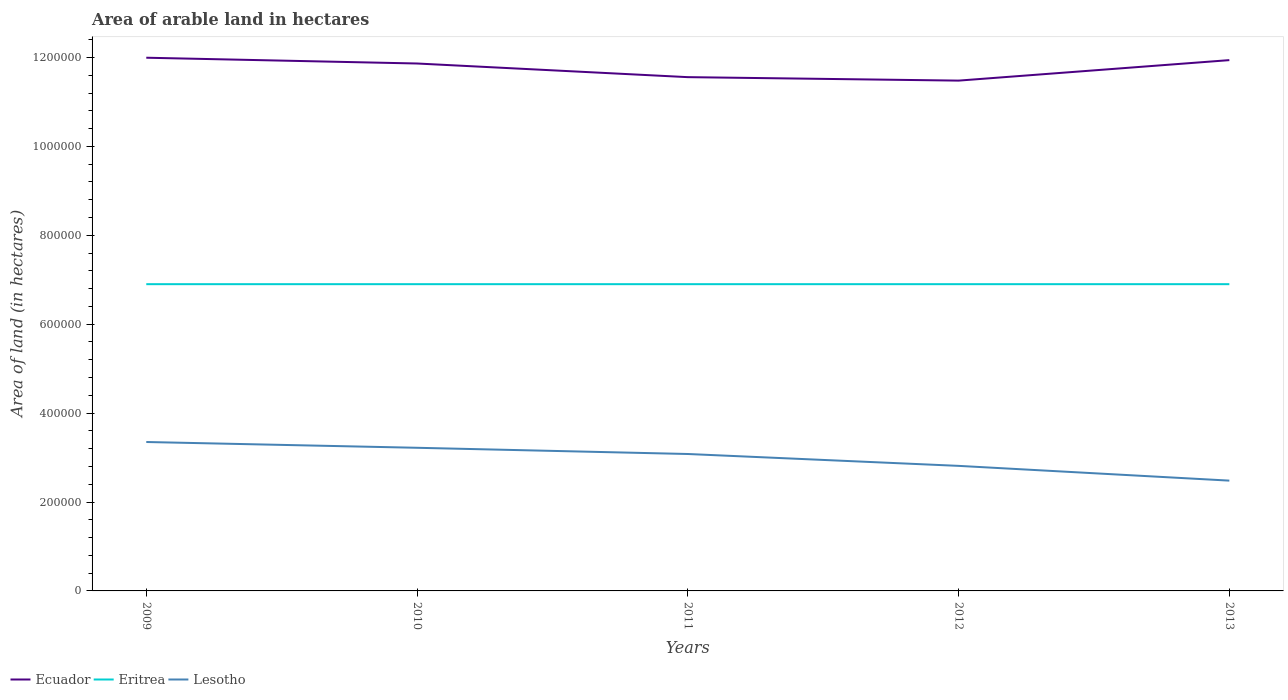Does the line corresponding to Ecuador intersect with the line corresponding to Eritrea?
Make the answer very short. No. Is the number of lines equal to the number of legend labels?
Provide a short and direct response. Yes. Across all years, what is the maximum total arable land in Lesotho?
Your answer should be compact. 2.48e+05. What is the total total arable land in Eritrea in the graph?
Keep it short and to the point. 0. What is the difference between the highest and the second highest total arable land in Lesotho?
Your response must be concise. 8.69e+04. What is the difference between the highest and the lowest total arable land in Ecuador?
Provide a short and direct response. 3. How many lines are there?
Keep it short and to the point. 3. What is the difference between two consecutive major ticks on the Y-axis?
Your response must be concise. 2.00e+05. Does the graph contain any zero values?
Give a very brief answer. No. Does the graph contain grids?
Offer a very short reply. No. Where does the legend appear in the graph?
Keep it short and to the point. Bottom left. How many legend labels are there?
Provide a succinct answer. 3. What is the title of the graph?
Ensure brevity in your answer.  Area of arable land in hectares. Does "Iran" appear as one of the legend labels in the graph?
Provide a short and direct response. No. What is the label or title of the Y-axis?
Give a very brief answer. Area of land (in hectares). What is the Area of land (in hectares) of Ecuador in 2009?
Ensure brevity in your answer.  1.20e+06. What is the Area of land (in hectares) of Eritrea in 2009?
Your response must be concise. 6.90e+05. What is the Area of land (in hectares) of Lesotho in 2009?
Keep it short and to the point. 3.35e+05. What is the Area of land (in hectares) in Ecuador in 2010?
Offer a terse response. 1.19e+06. What is the Area of land (in hectares) of Eritrea in 2010?
Provide a short and direct response. 6.90e+05. What is the Area of land (in hectares) of Lesotho in 2010?
Keep it short and to the point. 3.22e+05. What is the Area of land (in hectares) of Ecuador in 2011?
Offer a very short reply. 1.16e+06. What is the Area of land (in hectares) of Eritrea in 2011?
Provide a short and direct response. 6.90e+05. What is the Area of land (in hectares) of Lesotho in 2011?
Ensure brevity in your answer.  3.08e+05. What is the Area of land (in hectares) in Ecuador in 2012?
Your answer should be compact. 1.15e+06. What is the Area of land (in hectares) in Eritrea in 2012?
Provide a short and direct response. 6.90e+05. What is the Area of land (in hectares) of Lesotho in 2012?
Provide a succinct answer. 2.81e+05. What is the Area of land (in hectares) in Ecuador in 2013?
Offer a terse response. 1.19e+06. What is the Area of land (in hectares) in Eritrea in 2013?
Make the answer very short. 6.90e+05. What is the Area of land (in hectares) of Lesotho in 2013?
Ensure brevity in your answer.  2.48e+05. Across all years, what is the maximum Area of land (in hectares) in Ecuador?
Your answer should be very brief. 1.20e+06. Across all years, what is the maximum Area of land (in hectares) of Eritrea?
Your answer should be compact. 6.90e+05. Across all years, what is the maximum Area of land (in hectares) of Lesotho?
Offer a very short reply. 3.35e+05. Across all years, what is the minimum Area of land (in hectares) of Ecuador?
Your response must be concise. 1.15e+06. Across all years, what is the minimum Area of land (in hectares) in Eritrea?
Give a very brief answer. 6.90e+05. Across all years, what is the minimum Area of land (in hectares) in Lesotho?
Keep it short and to the point. 2.48e+05. What is the total Area of land (in hectares) of Ecuador in the graph?
Provide a succinct answer. 5.88e+06. What is the total Area of land (in hectares) in Eritrea in the graph?
Offer a very short reply. 3.45e+06. What is the total Area of land (in hectares) in Lesotho in the graph?
Offer a terse response. 1.49e+06. What is the difference between the Area of land (in hectares) in Ecuador in 2009 and that in 2010?
Your response must be concise. 1.30e+04. What is the difference between the Area of land (in hectares) of Lesotho in 2009 and that in 2010?
Offer a very short reply. 1.30e+04. What is the difference between the Area of land (in hectares) of Ecuador in 2009 and that in 2011?
Your answer should be very brief. 4.37e+04. What is the difference between the Area of land (in hectares) of Eritrea in 2009 and that in 2011?
Keep it short and to the point. 0. What is the difference between the Area of land (in hectares) in Lesotho in 2009 and that in 2011?
Provide a succinct answer. 2.70e+04. What is the difference between the Area of land (in hectares) in Ecuador in 2009 and that in 2012?
Your answer should be very brief. 5.15e+04. What is the difference between the Area of land (in hectares) in Lesotho in 2009 and that in 2012?
Ensure brevity in your answer.  5.37e+04. What is the difference between the Area of land (in hectares) in Ecuador in 2009 and that in 2013?
Provide a succinct answer. 5400. What is the difference between the Area of land (in hectares) of Lesotho in 2009 and that in 2013?
Offer a very short reply. 8.69e+04. What is the difference between the Area of land (in hectares) in Ecuador in 2010 and that in 2011?
Make the answer very short. 3.07e+04. What is the difference between the Area of land (in hectares) of Eritrea in 2010 and that in 2011?
Offer a very short reply. 0. What is the difference between the Area of land (in hectares) in Lesotho in 2010 and that in 2011?
Your response must be concise. 1.40e+04. What is the difference between the Area of land (in hectares) in Ecuador in 2010 and that in 2012?
Your response must be concise. 3.85e+04. What is the difference between the Area of land (in hectares) in Eritrea in 2010 and that in 2012?
Offer a very short reply. 0. What is the difference between the Area of land (in hectares) in Lesotho in 2010 and that in 2012?
Offer a terse response. 4.07e+04. What is the difference between the Area of land (in hectares) in Ecuador in 2010 and that in 2013?
Your answer should be compact. -7600. What is the difference between the Area of land (in hectares) in Lesotho in 2010 and that in 2013?
Your answer should be compact. 7.39e+04. What is the difference between the Area of land (in hectares) of Ecuador in 2011 and that in 2012?
Your answer should be compact. 7800. What is the difference between the Area of land (in hectares) in Eritrea in 2011 and that in 2012?
Offer a terse response. 0. What is the difference between the Area of land (in hectares) of Lesotho in 2011 and that in 2012?
Offer a very short reply. 2.67e+04. What is the difference between the Area of land (in hectares) in Ecuador in 2011 and that in 2013?
Ensure brevity in your answer.  -3.83e+04. What is the difference between the Area of land (in hectares) in Lesotho in 2011 and that in 2013?
Your answer should be compact. 5.99e+04. What is the difference between the Area of land (in hectares) in Ecuador in 2012 and that in 2013?
Your response must be concise. -4.61e+04. What is the difference between the Area of land (in hectares) in Eritrea in 2012 and that in 2013?
Provide a short and direct response. 0. What is the difference between the Area of land (in hectares) in Lesotho in 2012 and that in 2013?
Keep it short and to the point. 3.32e+04. What is the difference between the Area of land (in hectares) in Ecuador in 2009 and the Area of land (in hectares) in Eritrea in 2010?
Your answer should be very brief. 5.09e+05. What is the difference between the Area of land (in hectares) in Ecuador in 2009 and the Area of land (in hectares) in Lesotho in 2010?
Provide a short and direct response. 8.77e+05. What is the difference between the Area of land (in hectares) of Eritrea in 2009 and the Area of land (in hectares) of Lesotho in 2010?
Provide a succinct answer. 3.68e+05. What is the difference between the Area of land (in hectares) of Ecuador in 2009 and the Area of land (in hectares) of Eritrea in 2011?
Your response must be concise. 5.09e+05. What is the difference between the Area of land (in hectares) of Ecuador in 2009 and the Area of land (in hectares) of Lesotho in 2011?
Ensure brevity in your answer.  8.91e+05. What is the difference between the Area of land (in hectares) in Eritrea in 2009 and the Area of land (in hectares) in Lesotho in 2011?
Your response must be concise. 3.82e+05. What is the difference between the Area of land (in hectares) of Ecuador in 2009 and the Area of land (in hectares) of Eritrea in 2012?
Ensure brevity in your answer.  5.09e+05. What is the difference between the Area of land (in hectares) in Ecuador in 2009 and the Area of land (in hectares) in Lesotho in 2012?
Ensure brevity in your answer.  9.18e+05. What is the difference between the Area of land (in hectares) of Eritrea in 2009 and the Area of land (in hectares) of Lesotho in 2012?
Give a very brief answer. 4.09e+05. What is the difference between the Area of land (in hectares) of Ecuador in 2009 and the Area of land (in hectares) of Eritrea in 2013?
Provide a short and direct response. 5.09e+05. What is the difference between the Area of land (in hectares) of Ecuador in 2009 and the Area of land (in hectares) of Lesotho in 2013?
Give a very brief answer. 9.51e+05. What is the difference between the Area of land (in hectares) in Eritrea in 2009 and the Area of land (in hectares) in Lesotho in 2013?
Provide a short and direct response. 4.42e+05. What is the difference between the Area of land (in hectares) of Ecuador in 2010 and the Area of land (in hectares) of Eritrea in 2011?
Your answer should be very brief. 4.96e+05. What is the difference between the Area of land (in hectares) in Ecuador in 2010 and the Area of land (in hectares) in Lesotho in 2011?
Provide a succinct answer. 8.78e+05. What is the difference between the Area of land (in hectares) in Eritrea in 2010 and the Area of land (in hectares) in Lesotho in 2011?
Your answer should be compact. 3.82e+05. What is the difference between the Area of land (in hectares) in Ecuador in 2010 and the Area of land (in hectares) in Eritrea in 2012?
Give a very brief answer. 4.96e+05. What is the difference between the Area of land (in hectares) in Ecuador in 2010 and the Area of land (in hectares) in Lesotho in 2012?
Your response must be concise. 9.05e+05. What is the difference between the Area of land (in hectares) in Eritrea in 2010 and the Area of land (in hectares) in Lesotho in 2012?
Provide a short and direct response. 4.09e+05. What is the difference between the Area of land (in hectares) of Ecuador in 2010 and the Area of land (in hectares) of Eritrea in 2013?
Offer a terse response. 4.96e+05. What is the difference between the Area of land (in hectares) of Ecuador in 2010 and the Area of land (in hectares) of Lesotho in 2013?
Your response must be concise. 9.38e+05. What is the difference between the Area of land (in hectares) in Eritrea in 2010 and the Area of land (in hectares) in Lesotho in 2013?
Your response must be concise. 4.42e+05. What is the difference between the Area of land (in hectares) of Ecuador in 2011 and the Area of land (in hectares) of Eritrea in 2012?
Make the answer very short. 4.66e+05. What is the difference between the Area of land (in hectares) in Ecuador in 2011 and the Area of land (in hectares) in Lesotho in 2012?
Give a very brief answer. 8.74e+05. What is the difference between the Area of land (in hectares) of Eritrea in 2011 and the Area of land (in hectares) of Lesotho in 2012?
Provide a short and direct response. 4.09e+05. What is the difference between the Area of land (in hectares) of Ecuador in 2011 and the Area of land (in hectares) of Eritrea in 2013?
Your answer should be very brief. 4.66e+05. What is the difference between the Area of land (in hectares) of Ecuador in 2011 and the Area of land (in hectares) of Lesotho in 2013?
Your response must be concise. 9.08e+05. What is the difference between the Area of land (in hectares) in Eritrea in 2011 and the Area of land (in hectares) in Lesotho in 2013?
Your answer should be very brief. 4.42e+05. What is the difference between the Area of land (in hectares) of Ecuador in 2012 and the Area of land (in hectares) of Eritrea in 2013?
Offer a very short reply. 4.58e+05. What is the difference between the Area of land (in hectares) in Ecuador in 2012 and the Area of land (in hectares) in Lesotho in 2013?
Offer a terse response. 9.00e+05. What is the difference between the Area of land (in hectares) of Eritrea in 2012 and the Area of land (in hectares) of Lesotho in 2013?
Provide a short and direct response. 4.42e+05. What is the average Area of land (in hectares) of Ecuador per year?
Provide a succinct answer. 1.18e+06. What is the average Area of land (in hectares) in Eritrea per year?
Make the answer very short. 6.90e+05. What is the average Area of land (in hectares) in Lesotho per year?
Offer a very short reply. 2.99e+05. In the year 2009, what is the difference between the Area of land (in hectares) of Ecuador and Area of land (in hectares) of Eritrea?
Your response must be concise. 5.09e+05. In the year 2009, what is the difference between the Area of land (in hectares) of Ecuador and Area of land (in hectares) of Lesotho?
Offer a terse response. 8.64e+05. In the year 2009, what is the difference between the Area of land (in hectares) in Eritrea and Area of land (in hectares) in Lesotho?
Your answer should be very brief. 3.55e+05. In the year 2010, what is the difference between the Area of land (in hectares) in Ecuador and Area of land (in hectares) in Eritrea?
Make the answer very short. 4.96e+05. In the year 2010, what is the difference between the Area of land (in hectares) in Ecuador and Area of land (in hectares) in Lesotho?
Offer a terse response. 8.64e+05. In the year 2010, what is the difference between the Area of land (in hectares) in Eritrea and Area of land (in hectares) in Lesotho?
Keep it short and to the point. 3.68e+05. In the year 2011, what is the difference between the Area of land (in hectares) in Ecuador and Area of land (in hectares) in Eritrea?
Make the answer very short. 4.66e+05. In the year 2011, what is the difference between the Area of land (in hectares) of Ecuador and Area of land (in hectares) of Lesotho?
Ensure brevity in your answer.  8.48e+05. In the year 2011, what is the difference between the Area of land (in hectares) in Eritrea and Area of land (in hectares) in Lesotho?
Your response must be concise. 3.82e+05. In the year 2012, what is the difference between the Area of land (in hectares) of Ecuador and Area of land (in hectares) of Eritrea?
Your response must be concise. 4.58e+05. In the year 2012, what is the difference between the Area of land (in hectares) of Ecuador and Area of land (in hectares) of Lesotho?
Offer a very short reply. 8.67e+05. In the year 2012, what is the difference between the Area of land (in hectares) of Eritrea and Area of land (in hectares) of Lesotho?
Ensure brevity in your answer.  4.09e+05. In the year 2013, what is the difference between the Area of land (in hectares) in Ecuador and Area of land (in hectares) in Eritrea?
Offer a terse response. 5.04e+05. In the year 2013, what is the difference between the Area of land (in hectares) in Ecuador and Area of land (in hectares) in Lesotho?
Give a very brief answer. 9.46e+05. In the year 2013, what is the difference between the Area of land (in hectares) in Eritrea and Area of land (in hectares) in Lesotho?
Offer a terse response. 4.42e+05. What is the ratio of the Area of land (in hectares) of Ecuador in 2009 to that in 2010?
Your answer should be compact. 1.01. What is the ratio of the Area of land (in hectares) of Lesotho in 2009 to that in 2010?
Your answer should be very brief. 1.04. What is the ratio of the Area of land (in hectares) in Ecuador in 2009 to that in 2011?
Offer a very short reply. 1.04. What is the ratio of the Area of land (in hectares) in Eritrea in 2009 to that in 2011?
Your response must be concise. 1. What is the ratio of the Area of land (in hectares) in Lesotho in 2009 to that in 2011?
Provide a short and direct response. 1.09. What is the ratio of the Area of land (in hectares) of Ecuador in 2009 to that in 2012?
Your response must be concise. 1.04. What is the ratio of the Area of land (in hectares) of Lesotho in 2009 to that in 2012?
Your answer should be compact. 1.19. What is the ratio of the Area of land (in hectares) of Ecuador in 2009 to that in 2013?
Keep it short and to the point. 1. What is the ratio of the Area of land (in hectares) of Eritrea in 2009 to that in 2013?
Give a very brief answer. 1. What is the ratio of the Area of land (in hectares) of Lesotho in 2009 to that in 2013?
Your answer should be compact. 1.35. What is the ratio of the Area of land (in hectares) in Ecuador in 2010 to that in 2011?
Provide a succinct answer. 1.03. What is the ratio of the Area of land (in hectares) in Lesotho in 2010 to that in 2011?
Your response must be concise. 1.05. What is the ratio of the Area of land (in hectares) of Ecuador in 2010 to that in 2012?
Your response must be concise. 1.03. What is the ratio of the Area of land (in hectares) in Lesotho in 2010 to that in 2012?
Make the answer very short. 1.14. What is the ratio of the Area of land (in hectares) in Ecuador in 2010 to that in 2013?
Offer a terse response. 0.99. What is the ratio of the Area of land (in hectares) in Eritrea in 2010 to that in 2013?
Your response must be concise. 1. What is the ratio of the Area of land (in hectares) in Lesotho in 2010 to that in 2013?
Keep it short and to the point. 1.3. What is the ratio of the Area of land (in hectares) of Ecuador in 2011 to that in 2012?
Provide a succinct answer. 1.01. What is the ratio of the Area of land (in hectares) of Eritrea in 2011 to that in 2012?
Provide a short and direct response. 1. What is the ratio of the Area of land (in hectares) of Lesotho in 2011 to that in 2012?
Make the answer very short. 1.09. What is the ratio of the Area of land (in hectares) of Ecuador in 2011 to that in 2013?
Make the answer very short. 0.97. What is the ratio of the Area of land (in hectares) in Eritrea in 2011 to that in 2013?
Your answer should be compact. 1. What is the ratio of the Area of land (in hectares) in Lesotho in 2011 to that in 2013?
Provide a succinct answer. 1.24. What is the ratio of the Area of land (in hectares) in Ecuador in 2012 to that in 2013?
Your answer should be very brief. 0.96. What is the ratio of the Area of land (in hectares) in Lesotho in 2012 to that in 2013?
Give a very brief answer. 1.13. What is the difference between the highest and the second highest Area of land (in hectares) of Ecuador?
Your response must be concise. 5400. What is the difference between the highest and the second highest Area of land (in hectares) in Eritrea?
Offer a terse response. 0. What is the difference between the highest and the second highest Area of land (in hectares) in Lesotho?
Your response must be concise. 1.30e+04. What is the difference between the highest and the lowest Area of land (in hectares) in Ecuador?
Your answer should be very brief. 5.15e+04. What is the difference between the highest and the lowest Area of land (in hectares) in Eritrea?
Ensure brevity in your answer.  0. What is the difference between the highest and the lowest Area of land (in hectares) in Lesotho?
Your answer should be very brief. 8.69e+04. 